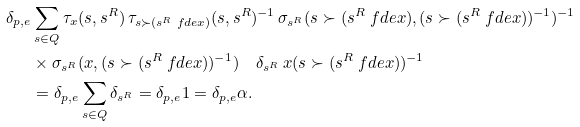<formula> <loc_0><loc_0><loc_500><loc_500>\delta _ { p , e } & \sum _ { s \in Q } \tau _ { x } ( s , s ^ { R } ) \, \tau _ { s \succ ( s ^ { R } \ f d e x ) } ( s , s ^ { R } ) ^ { - 1 } \, \sigma _ { s ^ { R } } ( s \succ ( s ^ { R } \ f d e x ) , ( s \succ ( s ^ { R } \ f d e x ) ) ^ { - 1 } ) ^ { - 1 } \\ & \times \sigma _ { s ^ { R } } ( x , ( s \succ ( s ^ { R } \ f d e x ) ) ^ { - 1 } ) \quad \delta _ { s ^ { R } } \, x ( s \succ ( s ^ { R } \ f d e x ) ) ^ { - 1 } \\ & = \delta _ { p , e } \sum _ { s \in Q } \delta _ { s ^ { R } } = \delta _ { p , e } 1 = \delta _ { p , e } \alpha .</formula> 